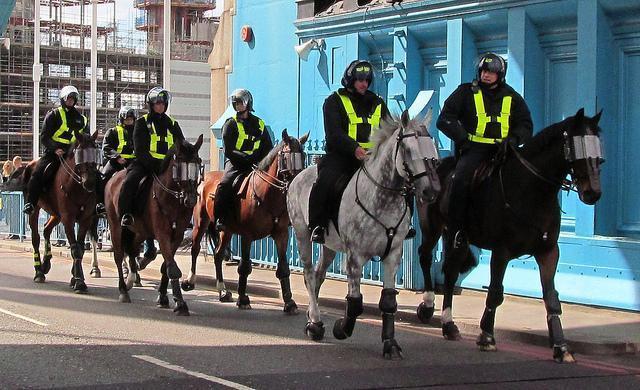How many people are riding?
Give a very brief answer. 6. How many horses are in the photo?
Give a very brief answer. 6. How many people are visible?
Give a very brief answer. 5. How many horses are there?
Give a very brief answer. 5. 